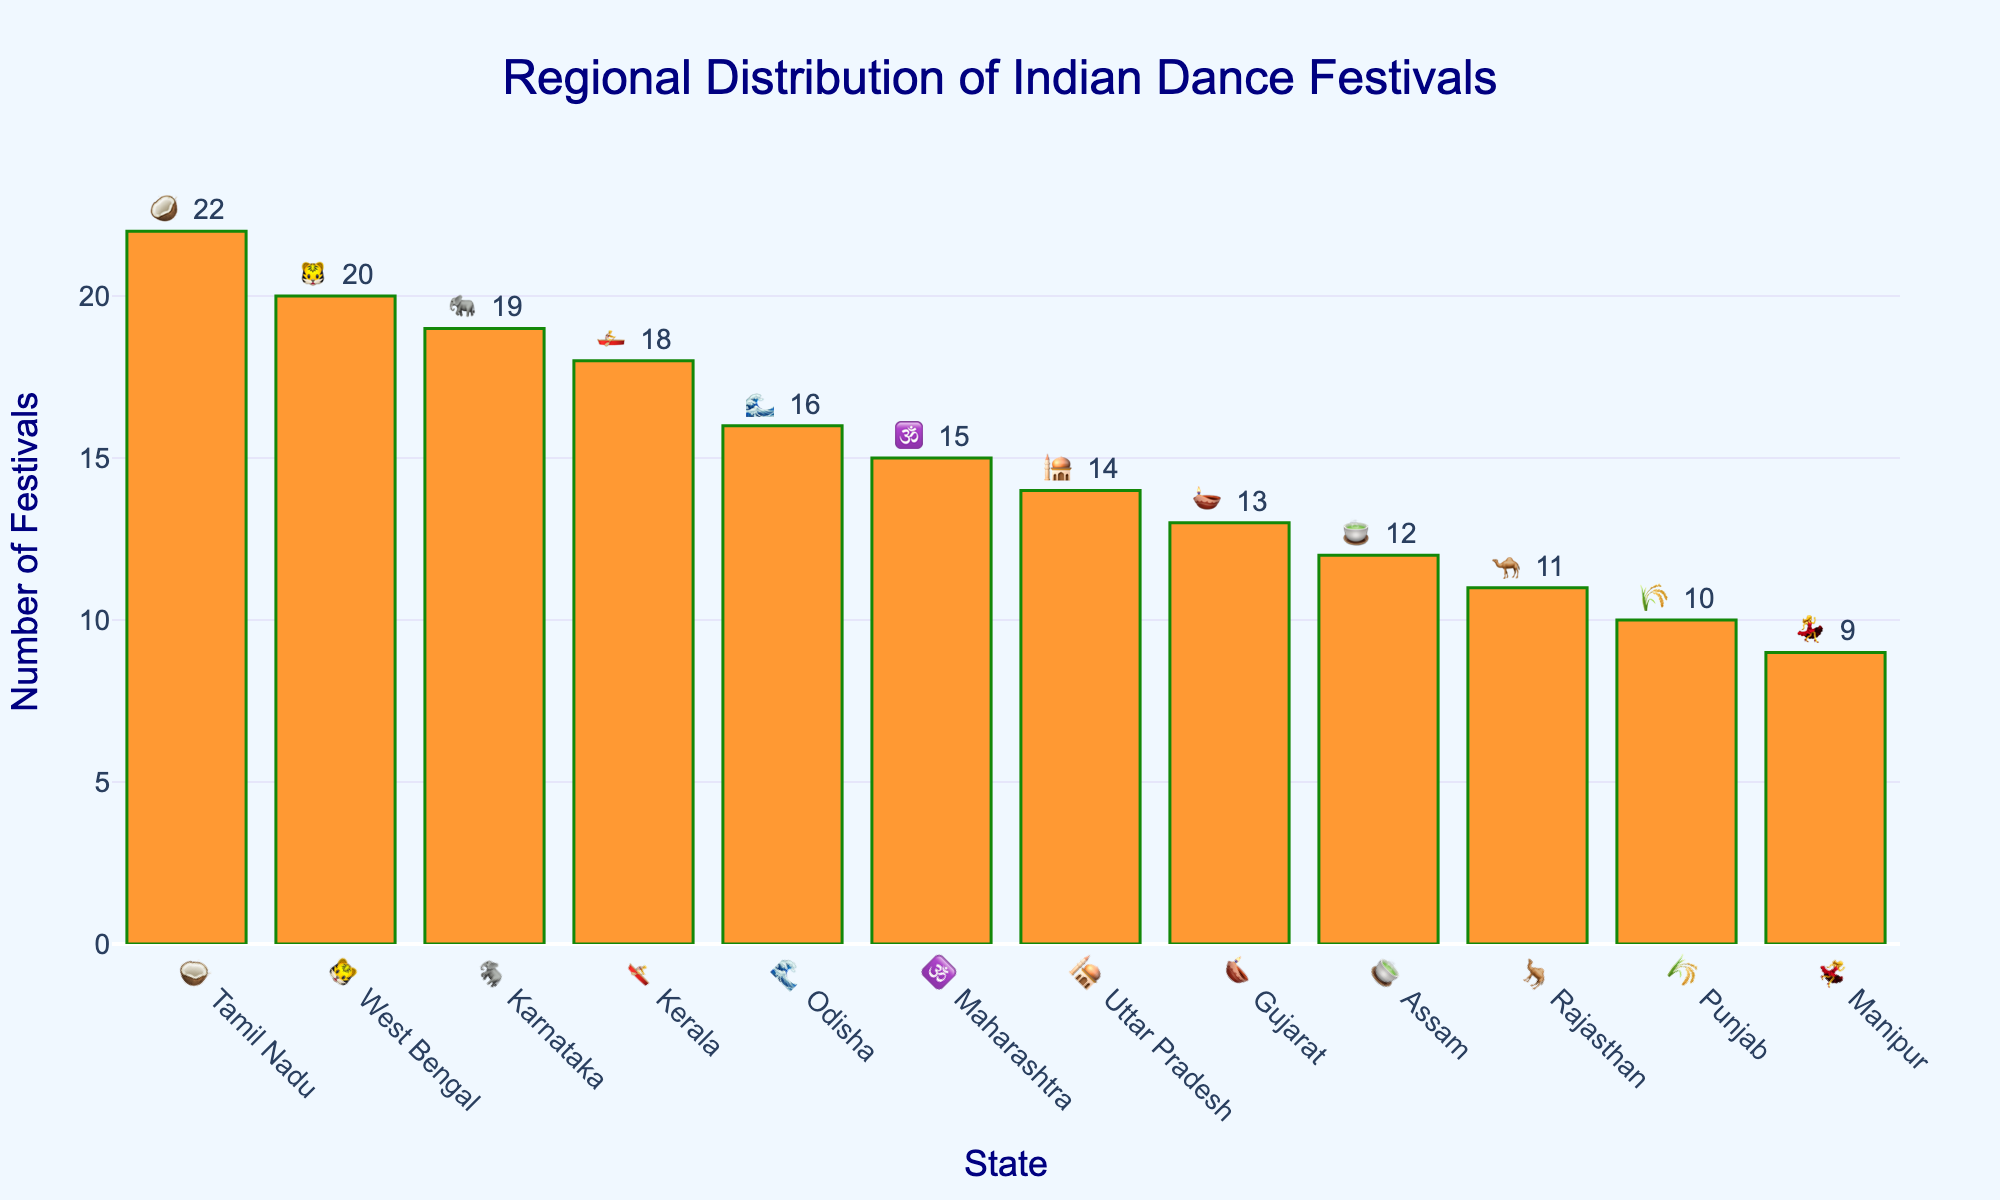Which state has the highest number of dance festivals? The highest bar represents Tamil Nadu with 22 dance festivals.
Answer: Tamil Nadu 🥥 What is the title of the chart? The title is shown at the top center of the chart and reads 'Regional Distribution of Indian Dance Festivals'.
Answer: Regional Distribution of Indian Dance Festivals What is the range of the y-axis? The y-axis ranges from 0 to a little above 22, indicated by the spacing of the grid lines.
Answer: 0 to slightly above 22 Which state has the least number of dance festivals? The shortest bar represents Manipur with 9 dance festivals.
Answer: Manipur 💃 How many dance festivals are held in Kerala? The bar corresponding to Kerala shows 18 dance festivals.
Answer: 18 🚣 What are the emojis used to represent Gujarat and Assam? The emoji for Gujarat is 🪔 and for Assam is 🍵, found at the edges of the bars for these states.
Answer: 🪔 and 🍵 How many more dance festivals are held in Tamil Nadu compared to Maharashtra? Tamil Nadu holds 22 festivals, and Maharashtra holds 15. The difference is calculated as 22 - 15 = 7.
Answer: 7 What is the sum of dance festivals held in Uttar Pradesh and Punjab? Uttar Pradesh has 14 festivals and Punjab has 10. The sum is 14 + 10 = 24.
Answer: 24 Compare the number of dance festivals in Karnataka and West Bengal. Which one has more and by how much? Karnataka has 19 festivals, while West Bengal has 20. West Bengal has 1 more festival than Karnataka.
Answer: West Bengal by 1 🐯 Which color is used for the bars in the chart? The bars are colored saffron, representative of a color from the Indian flag.
Answer: Saffron 